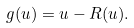Convert formula to latex. <formula><loc_0><loc_0><loc_500><loc_500>g ( u ) = u - R ( u ) .</formula> 